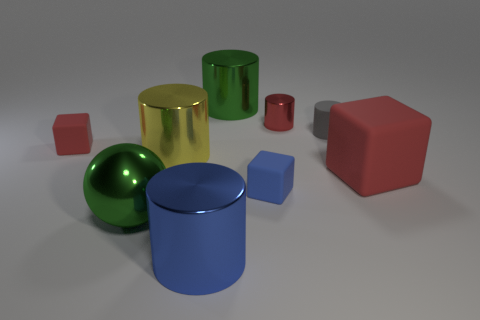What number of objects are either tiny purple matte blocks or metallic cylinders?
Offer a very short reply. 4. What is the material of the red thing that is in front of the small red thing left of the small metallic cylinder?
Offer a very short reply. Rubber. Are there any blue spheres that have the same material as the yellow cylinder?
Make the answer very short. No. What is the shape of the green thing behind the matte thing that is on the left side of the large yellow metal cylinder behind the large green shiny sphere?
Offer a very short reply. Cylinder. What is the small blue object made of?
Provide a succinct answer. Rubber. There is a big block that is the same material as the tiny gray object; what color is it?
Keep it short and to the point. Red. Is there a big green shiny cylinder to the right of the small matte object that is in front of the tiny red block?
Provide a succinct answer. No. What number of other things are the same shape as the big yellow metallic object?
Your response must be concise. 4. There is a tiny matte object that is left of the big blue shiny object; is it the same shape as the big green metallic object on the left side of the green cylinder?
Give a very brief answer. No. There is a big green metallic thing in front of the rubber thing left of the yellow thing; what number of tiny red things are on the right side of it?
Provide a succinct answer. 1. 